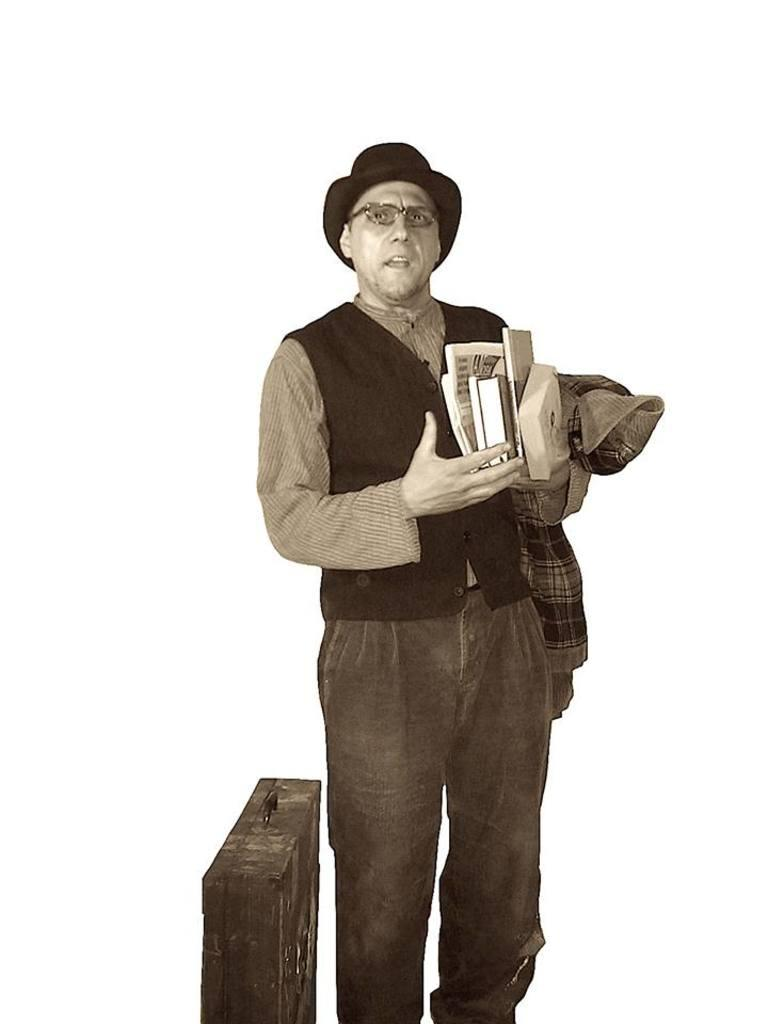Who is the main subject in the foreground of the image? There is a man in the foreground of the image. What is the man holding in his hands? The man is holding books and a coat in his hand. What object is the man standing beside? The man is standing beside a suitcase. What is the color of the background in the image? The background of the image is white. What type of place is the man using the coat in the image? The image does not provide information about the type of place or the use of the coat. 